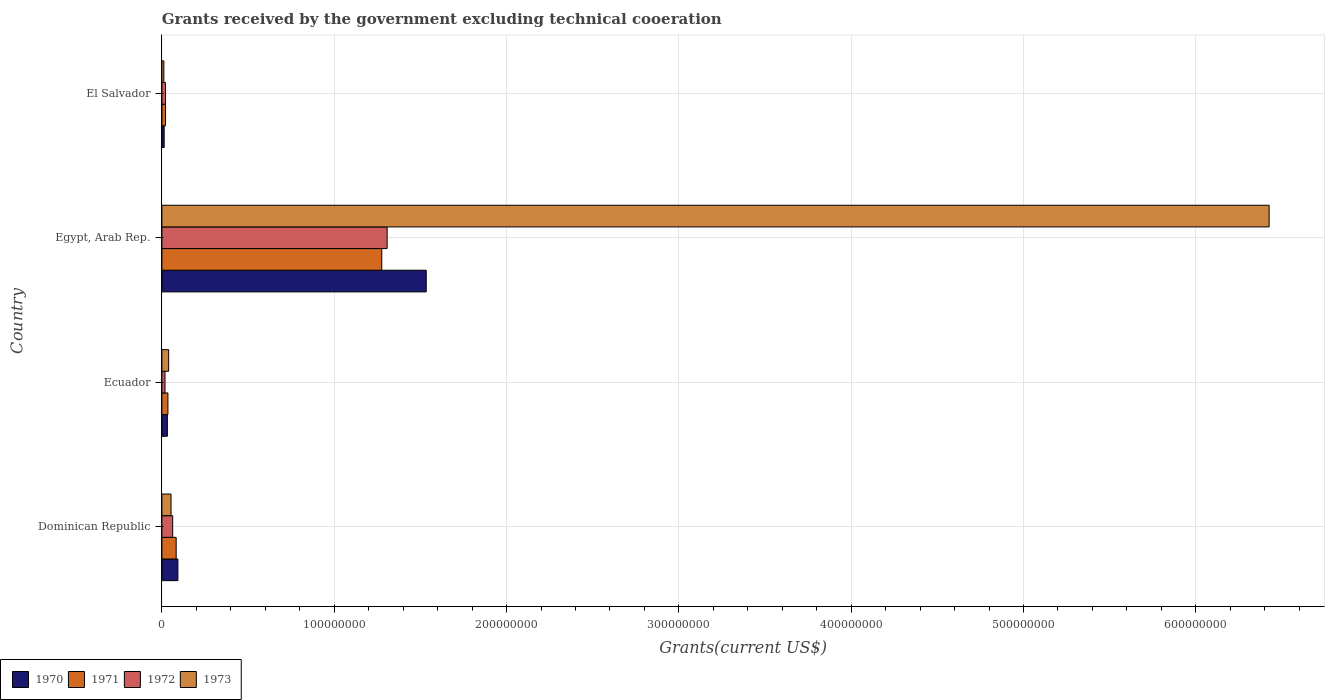How many different coloured bars are there?
Provide a short and direct response. 4. Are the number of bars on each tick of the Y-axis equal?
Offer a terse response. Yes. How many bars are there on the 2nd tick from the top?
Your response must be concise. 4. What is the label of the 2nd group of bars from the top?
Keep it short and to the point. Egypt, Arab Rep. What is the total grants received by the government in 1973 in Ecuador?
Provide a short and direct response. 3.92e+06. Across all countries, what is the maximum total grants received by the government in 1973?
Keep it short and to the point. 6.43e+08. Across all countries, what is the minimum total grants received by the government in 1972?
Your answer should be compact. 1.80e+06. In which country was the total grants received by the government in 1973 maximum?
Keep it short and to the point. Egypt, Arab Rep. In which country was the total grants received by the government in 1970 minimum?
Your response must be concise. El Salvador. What is the total total grants received by the government in 1970 in the graph?
Ensure brevity in your answer.  1.67e+08. What is the difference between the total grants received by the government in 1973 in Dominican Republic and that in El Salvador?
Ensure brevity in your answer.  4.15e+06. What is the difference between the total grants received by the government in 1970 in Ecuador and the total grants received by the government in 1972 in El Salvador?
Make the answer very short. 1.11e+06. What is the average total grants received by the government in 1972 per country?
Offer a very short reply. 3.52e+07. What is the difference between the total grants received by the government in 1971 and total grants received by the government in 1973 in Ecuador?
Offer a terse response. -4.20e+05. What is the ratio of the total grants received by the government in 1972 in Dominican Republic to that in Egypt, Arab Rep.?
Ensure brevity in your answer.  0.05. What is the difference between the highest and the second highest total grants received by the government in 1972?
Offer a terse response. 1.24e+08. What is the difference between the highest and the lowest total grants received by the government in 1970?
Your answer should be very brief. 1.52e+08. In how many countries, is the total grants received by the government in 1972 greater than the average total grants received by the government in 1972 taken over all countries?
Your response must be concise. 1. Is the sum of the total grants received by the government in 1970 in Egypt, Arab Rep. and El Salvador greater than the maximum total grants received by the government in 1973 across all countries?
Your answer should be compact. No. What does the 4th bar from the top in Dominican Republic represents?
Make the answer very short. 1970. What does the 2nd bar from the bottom in Dominican Republic represents?
Give a very brief answer. 1971. Is it the case that in every country, the sum of the total grants received by the government in 1971 and total grants received by the government in 1972 is greater than the total grants received by the government in 1970?
Ensure brevity in your answer.  Yes. Are all the bars in the graph horizontal?
Keep it short and to the point. Yes. How many countries are there in the graph?
Give a very brief answer. 4. What is the difference between two consecutive major ticks on the X-axis?
Offer a very short reply. 1.00e+08. Are the values on the major ticks of X-axis written in scientific E-notation?
Keep it short and to the point. No. Does the graph contain any zero values?
Keep it short and to the point. No. What is the title of the graph?
Your answer should be very brief. Grants received by the government excluding technical cooeration. Does "1989" appear as one of the legend labels in the graph?
Your answer should be very brief. No. What is the label or title of the X-axis?
Keep it short and to the point. Grants(current US$). What is the Grants(current US$) of 1970 in Dominican Republic?
Offer a very short reply. 9.28e+06. What is the Grants(current US$) of 1971 in Dominican Republic?
Provide a succinct answer. 8.28e+06. What is the Grants(current US$) in 1972 in Dominican Republic?
Keep it short and to the point. 6.25e+06. What is the Grants(current US$) of 1973 in Dominican Republic?
Provide a short and direct response. 5.30e+06. What is the Grants(current US$) of 1970 in Ecuador?
Ensure brevity in your answer.  3.18e+06. What is the Grants(current US$) in 1971 in Ecuador?
Your response must be concise. 3.50e+06. What is the Grants(current US$) in 1972 in Ecuador?
Give a very brief answer. 1.80e+06. What is the Grants(current US$) of 1973 in Ecuador?
Provide a succinct answer. 3.92e+06. What is the Grants(current US$) in 1970 in Egypt, Arab Rep.?
Offer a very short reply. 1.53e+08. What is the Grants(current US$) in 1971 in Egypt, Arab Rep.?
Make the answer very short. 1.28e+08. What is the Grants(current US$) in 1972 in Egypt, Arab Rep.?
Your answer should be very brief. 1.31e+08. What is the Grants(current US$) in 1973 in Egypt, Arab Rep.?
Provide a short and direct response. 6.43e+08. What is the Grants(current US$) of 1970 in El Salvador?
Your answer should be very brief. 1.32e+06. What is the Grants(current US$) of 1971 in El Salvador?
Provide a short and direct response. 2.08e+06. What is the Grants(current US$) in 1972 in El Salvador?
Give a very brief answer. 2.07e+06. What is the Grants(current US$) of 1973 in El Salvador?
Provide a succinct answer. 1.15e+06. Across all countries, what is the maximum Grants(current US$) in 1970?
Offer a very short reply. 1.53e+08. Across all countries, what is the maximum Grants(current US$) in 1971?
Offer a terse response. 1.28e+08. Across all countries, what is the maximum Grants(current US$) in 1972?
Your answer should be compact. 1.31e+08. Across all countries, what is the maximum Grants(current US$) in 1973?
Ensure brevity in your answer.  6.43e+08. Across all countries, what is the minimum Grants(current US$) of 1970?
Give a very brief answer. 1.32e+06. Across all countries, what is the minimum Grants(current US$) of 1971?
Give a very brief answer. 2.08e+06. Across all countries, what is the minimum Grants(current US$) in 1972?
Offer a very short reply. 1.80e+06. Across all countries, what is the minimum Grants(current US$) of 1973?
Ensure brevity in your answer.  1.15e+06. What is the total Grants(current US$) in 1970 in the graph?
Make the answer very short. 1.67e+08. What is the total Grants(current US$) in 1971 in the graph?
Ensure brevity in your answer.  1.41e+08. What is the total Grants(current US$) of 1972 in the graph?
Give a very brief answer. 1.41e+08. What is the total Grants(current US$) in 1973 in the graph?
Ensure brevity in your answer.  6.53e+08. What is the difference between the Grants(current US$) in 1970 in Dominican Republic and that in Ecuador?
Provide a short and direct response. 6.10e+06. What is the difference between the Grants(current US$) of 1971 in Dominican Republic and that in Ecuador?
Give a very brief answer. 4.78e+06. What is the difference between the Grants(current US$) of 1972 in Dominican Republic and that in Ecuador?
Your answer should be compact. 4.45e+06. What is the difference between the Grants(current US$) in 1973 in Dominican Republic and that in Ecuador?
Your answer should be compact. 1.38e+06. What is the difference between the Grants(current US$) of 1970 in Dominican Republic and that in Egypt, Arab Rep.?
Your answer should be very brief. -1.44e+08. What is the difference between the Grants(current US$) of 1971 in Dominican Republic and that in Egypt, Arab Rep.?
Keep it short and to the point. -1.19e+08. What is the difference between the Grants(current US$) of 1972 in Dominican Republic and that in Egypt, Arab Rep.?
Make the answer very short. -1.24e+08. What is the difference between the Grants(current US$) in 1973 in Dominican Republic and that in Egypt, Arab Rep.?
Ensure brevity in your answer.  -6.37e+08. What is the difference between the Grants(current US$) in 1970 in Dominican Republic and that in El Salvador?
Make the answer very short. 7.96e+06. What is the difference between the Grants(current US$) in 1971 in Dominican Republic and that in El Salvador?
Offer a very short reply. 6.20e+06. What is the difference between the Grants(current US$) in 1972 in Dominican Republic and that in El Salvador?
Provide a short and direct response. 4.18e+06. What is the difference between the Grants(current US$) of 1973 in Dominican Republic and that in El Salvador?
Provide a short and direct response. 4.15e+06. What is the difference between the Grants(current US$) of 1970 in Ecuador and that in Egypt, Arab Rep.?
Provide a short and direct response. -1.50e+08. What is the difference between the Grants(current US$) of 1971 in Ecuador and that in Egypt, Arab Rep.?
Provide a succinct answer. -1.24e+08. What is the difference between the Grants(current US$) of 1972 in Ecuador and that in Egypt, Arab Rep.?
Your answer should be very brief. -1.29e+08. What is the difference between the Grants(current US$) in 1973 in Ecuador and that in Egypt, Arab Rep.?
Offer a terse response. -6.39e+08. What is the difference between the Grants(current US$) in 1970 in Ecuador and that in El Salvador?
Offer a terse response. 1.86e+06. What is the difference between the Grants(current US$) of 1971 in Ecuador and that in El Salvador?
Ensure brevity in your answer.  1.42e+06. What is the difference between the Grants(current US$) in 1972 in Ecuador and that in El Salvador?
Make the answer very short. -2.70e+05. What is the difference between the Grants(current US$) in 1973 in Ecuador and that in El Salvador?
Keep it short and to the point. 2.77e+06. What is the difference between the Grants(current US$) in 1970 in Egypt, Arab Rep. and that in El Salvador?
Your response must be concise. 1.52e+08. What is the difference between the Grants(current US$) in 1971 in Egypt, Arab Rep. and that in El Salvador?
Offer a very short reply. 1.26e+08. What is the difference between the Grants(current US$) in 1972 in Egypt, Arab Rep. and that in El Salvador?
Make the answer very short. 1.29e+08. What is the difference between the Grants(current US$) of 1973 in Egypt, Arab Rep. and that in El Salvador?
Offer a terse response. 6.41e+08. What is the difference between the Grants(current US$) in 1970 in Dominican Republic and the Grants(current US$) in 1971 in Ecuador?
Offer a terse response. 5.78e+06. What is the difference between the Grants(current US$) of 1970 in Dominican Republic and the Grants(current US$) of 1972 in Ecuador?
Your response must be concise. 7.48e+06. What is the difference between the Grants(current US$) in 1970 in Dominican Republic and the Grants(current US$) in 1973 in Ecuador?
Make the answer very short. 5.36e+06. What is the difference between the Grants(current US$) of 1971 in Dominican Republic and the Grants(current US$) of 1972 in Ecuador?
Your response must be concise. 6.48e+06. What is the difference between the Grants(current US$) in 1971 in Dominican Republic and the Grants(current US$) in 1973 in Ecuador?
Offer a very short reply. 4.36e+06. What is the difference between the Grants(current US$) in 1972 in Dominican Republic and the Grants(current US$) in 1973 in Ecuador?
Your response must be concise. 2.33e+06. What is the difference between the Grants(current US$) of 1970 in Dominican Republic and the Grants(current US$) of 1971 in Egypt, Arab Rep.?
Give a very brief answer. -1.18e+08. What is the difference between the Grants(current US$) in 1970 in Dominican Republic and the Grants(current US$) in 1972 in Egypt, Arab Rep.?
Your response must be concise. -1.21e+08. What is the difference between the Grants(current US$) of 1970 in Dominican Republic and the Grants(current US$) of 1973 in Egypt, Arab Rep.?
Your answer should be very brief. -6.33e+08. What is the difference between the Grants(current US$) in 1971 in Dominican Republic and the Grants(current US$) in 1972 in Egypt, Arab Rep.?
Offer a terse response. -1.22e+08. What is the difference between the Grants(current US$) of 1971 in Dominican Republic and the Grants(current US$) of 1973 in Egypt, Arab Rep.?
Provide a succinct answer. -6.34e+08. What is the difference between the Grants(current US$) of 1972 in Dominican Republic and the Grants(current US$) of 1973 in Egypt, Arab Rep.?
Make the answer very short. -6.36e+08. What is the difference between the Grants(current US$) in 1970 in Dominican Republic and the Grants(current US$) in 1971 in El Salvador?
Provide a succinct answer. 7.20e+06. What is the difference between the Grants(current US$) in 1970 in Dominican Republic and the Grants(current US$) in 1972 in El Salvador?
Your answer should be very brief. 7.21e+06. What is the difference between the Grants(current US$) of 1970 in Dominican Republic and the Grants(current US$) of 1973 in El Salvador?
Give a very brief answer. 8.13e+06. What is the difference between the Grants(current US$) of 1971 in Dominican Republic and the Grants(current US$) of 1972 in El Salvador?
Ensure brevity in your answer.  6.21e+06. What is the difference between the Grants(current US$) of 1971 in Dominican Republic and the Grants(current US$) of 1973 in El Salvador?
Give a very brief answer. 7.13e+06. What is the difference between the Grants(current US$) of 1972 in Dominican Republic and the Grants(current US$) of 1973 in El Salvador?
Your answer should be compact. 5.10e+06. What is the difference between the Grants(current US$) in 1970 in Ecuador and the Grants(current US$) in 1971 in Egypt, Arab Rep.?
Your response must be concise. -1.24e+08. What is the difference between the Grants(current US$) of 1970 in Ecuador and the Grants(current US$) of 1972 in Egypt, Arab Rep.?
Offer a very short reply. -1.28e+08. What is the difference between the Grants(current US$) in 1970 in Ecuador and the Grants(current US$) in 1973 in Egypt, Arab Rep.?
Your answer should be compact. -6.39e+08. What is the difference between the Grants(current US$) in 1971 in Ecuador and the Grants(current US$) in 1972 in Egypt, Arab Rep.?
Ensure brevity in your answer.  -1.27e+08. What is the difference between the Grants(current US$) in 1971 in Ecuador and the Grants(current US$) in 1973 in Egypt, Arab Rep.?
Your answer should be very brief. -6.39e+08. What is the difference between the Grants(current US$) of 1972 in Ecuador and the Grants(current US$) of 1973 in Egypt, Arab Rep.?
Provide a short and direct response. -6.41e+08. What is the difference between the Grants(current US$) of 1970 in Ecuador and the Grants(current US$) of 1971 in El Salvador?
Provide a succinct answer. 1.10e+06. What is the difference between the Grants(current US$) in 1970 in Ecuador and the Grants(current US$) in 1972 in El Salvador?
Offer a terse response. 1.11e+06. What is the difference between the Grants(current US$) in 1970 in Ecuador and the Grants(current US$) in 1973 in El Salvador?
Offer a terse response. 2.03e+06. What is the difference between the Grants(current US$) in 1971 in Ecuador and the Grants(current US$) in 1972 in El Salvador?
Provide a succinct answer. 1.43e+06. What is the difference between the Grants(current US$) in 1971 in Ecuador and the Grants(current US$) in 1973 in El Salvador?
Make the answer very short. 2.35e+06. What is the difference between the Grants(current US$) of 1972 in Ecuador and the Grants(current US$) of 1973 in El Salvador?
Provide a succinct answer. 6.50e+05. What is the difference between the Grants(current US$) in 1970 in Egypt, Arab Rep. and the Grants(current US$) in 1971 in El Salvador?
Offer a very short reply. 1.51e+08. What is the difference between the Grants(current US$) of 1970 in Egypt, Arab Rep. and the Grants(current US$) of 1972 in El Salvador?
Offer a terse response. 1.51e+08. What is the difference between the Grants(current US$) in 1970 in Egypt, Arab Rep. and the Grants(current US$) in 1973 in El Salvador?
Provide a succinct answer. 1.52e+08. What is the difference between the Grants(current US$) in 1971 in Egypt, Arab Rep. and the Grants(current US$) in 1972 in El Salvador?
Your answer should be compact. 1.26e+08. What is the difference between the Grants(current US$) of 1971 in Egypt, Arab Rep. and the Grants(current US$) of 1973 in El Salvador?
Offer a terse response. 1.26e+08. What is the difference between the Grants(current US$) of 1972 in Egypt, Arab Rep. and the Grants(current US$) of 1973 in El Salvador?
Provide a short and direct response. 1.30e+08. What is the average Grants(current US$) in 1970 per country?
Give a very brief answer. 4.18e+07. What is the average Grants(current US$) in 1971 per country?
Your answer should be compact. 3.54e+07. What is the average Grants(current US$) in 1972 per country?
Keep it short and to the point. 3.52e+07. What is the average Grants(current US$) in 1973 per country?
Ensure brevity in your answer.  1.63e+08. What is the difference between the Grants(current US$) of 1970 and Grants(current US$) of 1972 in Dominican Republic?
Offer a very short reply. 3.03e+06. What is the difference between the Grants(current US$) of 1970 and Grants(current US$) of 1973 in Dominican Republic?
Give a very brief answer. 3.98e+06. What is the difference between the Grants(current US$) in 1971 and Grants(current US$) in 1972 in Dominican Republic?
Provide a short and direct response. 2.03e+06. What is the difference between the Grants(current US$) in 1971 and Grants(current US$) in 1973 in Dominican Republic?
Provide a short and direct response. 2.98e+06. What is the difference between the Grants(current US$) of 1972 and Grants(current US$) of 1973 in Dominican Republic?
Make the answer very short. 9.50e+05. What is the difference between the Grants(current US$) in 1970 and Grants(current US$) in 1971 in Ecuador?
Ensure brevity in your answer.  -3.20e+05. What is the difference between the Grants(current US$) in 1970 and Grants(current US$) in 1972 in Ecuador?
Make the answer very short. 1.38e+06. What is the difference between the Grants(current US$) in 1970 and Grants(current US$) in 1973 in Ecuador?
Ensure brevity in your answer.  -7.40e+05. What is the difference between the Grants(current US$) of 1971 and Grants(current US$) of 1972 in Ecuador?
Keep it short and to the point. 1.70e+06. What is the difference between the Grants(current US$) of 1971 and Grants(current US$) of 1973 in Ecuador?
Your response must be concise. -4.20e+05. What is the difference between the Grants(current US$) in 1972 and Grants(current US$) in 1973 in Ecuador?
Your response must be concise. -2.12e+06. What is the difference between the Grants(current US$) of 1970 and Grants(current US$) of 1971 in Egypt, Arab Rep.?
Offer a very short reply. 2.58e+07. What is the difference between the Grants(current US$) of 1970 and Grants(current US$) of 1972 in Egypt, Arab Rep.?
Make the answer very short. 2.27e+07. What is the difference between the Grants(current US$) of 1970 and Grants(current US$) of 1973 in Egypt, Arab Rep.?
Make the answer very short. -4.89e+08. What is the difference between the Grants(current US$) in 1971 and Grants(current US$) in 1972 in Egypt, Arab Rep.?
Ensure brevity in your answer.  -3.12e+06. What is the difference between the Grants(current US$) in 1971 and Grants(current US$) in 1973 in Egypt, Arab Rep.?
Provide a succinct answer. -5.15e+08. What is the difference between the Grants(current US$) of 1972 and Grants(current US$) of 1973 in Egypt, Arab Rep.?
Keep it short and to the point. -5.12e+08. What is the difference between the Grants(current US$) in 1970 and Grants(current US$) in 1971 in El Salvador?
Provide a succinct answer. -7.60e+05. What is the difference between the Grants(current US$) in 1970 and Grants(current US$) in 1972 in El Salvador?
Make the answer very short. -7.50e+05. What is the difference between the Grants(current US$) of 1970 and Grants(current US$) of 1973 in El Salvador?
Make the answer very short. 1.70e+05. What is the difference between the Grants(current US$) in 1971 and Grants(current US$) in 1973 in El Salvador?
Ensure brevity in your answer.  9.30e+05. What is the difference between the Grants(current US$) of 1972 and Grants(current US$) of 1973 in El Salvador?
Your answer should be very brief. 9.20e+05. What is the ratio of the Grants(current US$) of 1970 in Dominican Republic to that in Ecuador?
Ensure brevity in your answer.  2.92. What is the ratio of the Grants(current US$) in 1971 in Dominican Republic to that in Ecuador?
Give a very brief answer. 2.37. What is the ratio of the Grants(current US$) in 1972 in Dominican Republic to that in Ecuador?
Keep it short and to the point. 3.47. What is the ratio of the Grants(current US$) in 1973 in Dominican Republic to that in Ecuador?
Offer a very short reply. 1.35. What is the ratio of the Grants(current US$) of 1970 in Dominican Republic to that in Egypt, Arab Rep.?
Ensure brevity in your answer.  0.06. What is the ratio of the Grants(current US$) of 1971 in Dominican Republic to that in Egypt, Arab Rep.?
Your answer should be very brief. 0.06. What is the ratio of the Grants(current US$) of 1972 in Dominican Republic to that in Egypt, Arab Rep.?
Keep it short and to the point. 0.05. What is the ratio of the Grants(current US$) of 1973 in Dominican Republic to that in Egypt, Arab Rep.?
Your answer should be very brief. 0.01. What is the ratio of the Grants(current US$) in 1970 in Dominican Republic to that in El Salvador?
Keep it short and to the point. 7.03. What is the ratio of the Grants(current US$) in 1971 in Dominican Republic to that in El Salvador?
Provide a succinct answer. 3.98. What is the ratio of the Grants(current US$) of 1972 in Dominican Republic to that in El Salvador?
Provide a short and direct response. 3.02. What is the ratio of the Grants(current US$) of 1973 in Dominican Republic to that in El Salvador?
Make the answer very short. 4.61. What is the ratio of the Grants(current US$) of 1970 in Ecuador to that in Egypt, Arab Rep.?
Ensure brevity in your answer.  0.02. What is the ratio of the Grants(current US$) in 1971 in Ecuador to that in Egypt, Arab Rep.?
Your answer should be compact. 0.03. What is the ratio of the Grants(current US$) in 1972 in Ecuador to that in Egypt, Arab Rep.?
Provide a succinct answer. 0.01. What is the ratio of the Grants(current US$) of 1973 in Ecuador to that in Egypt, Arab Rep.?
Make the answer very short. 0.01. What is the ratio of the Grants(current US$) in 1970 in Ecuador to that in El Salvador?
Your answer should be very brief. 2.41. What is the ratio of the Grants(current US$) of 1971 in Ecuador to that in El Salvador?
Provide a short and direct response. 1.68. What is the ratio of the Grants(current US$) in 1972 in Ecuador to that in El Salvador?
Offer a terse response. 0.87. What is the ratio of the Grants(current US$) in 1973 in Ecuador to that in El Salvador?
Keep it short and to the point. 3.41. What is the ratio of the Grants(current US$) in 1970 in Egypt, Arab Rep. to that in El Salvador?
Your response must be concise. 116.21. What is the ratio of the Grants(current US$) of 1971 in Egypt, Arab Rep. to that in El Salvador?
Provide a succinct answer. 61.34. What is the ratio of the Grants(current US$) in 1972 in Egypt, Arab Rep. to that in El Salvador?
Make the answer very short. 63.14. What is the ratio of the Grants(current US$) of 1973 in Egypt, Arab Rep. to that in El Salvador?
Keep it short and to the point. 558.74. What is the difference between the highest and the second highest Grants(current US$) of 1970?
Offer a terse response. 1.44e+08. What is the difference between the highest and the second highest Grants(current US$) of 1971?
Provide a succinct answer. 1.19e+08. What is the difference between the highest and the second highest Grants(current US$) in 1972?
Offer a very short reply. 1.24e+08. What is the difference between the highest and the second highest Grants(current US$) of 1973?
Provide a succinct answer. 6.37e+08. What is the difference between the highest and the lowest Grants(current US$) of 1970?
Provide a short and direct response. 1.52e+08. What is the difference between the highest and the lowest Grants(current US$) in 1971?
Your response must be concise. 1.26e+08. What is the difference between the highest and the lowest Grants(current US$) in 1972?
Ensure brevity in your answer.  1.29e+08. What is the difference between the highest and the lowest Grants(current US$) in 1973?
Offer a terse response. 6.41e+08. 